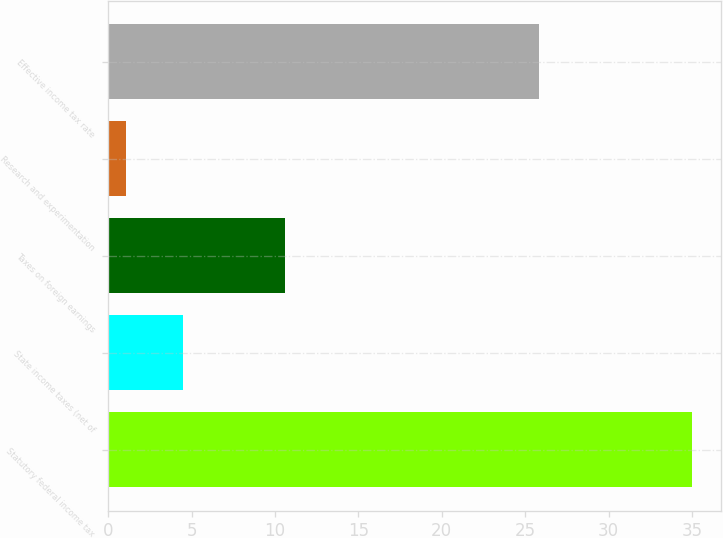Convert chart. <chart><loc_0><loc_0><loc_500><loc_500><bar_chart><fcel>Statutory federal income tax<fcel>State income taxes (net of<fcel>Taxes on foreign earnings<fcel>Research and experimentation<fcel>Effective income tax rate<nl><fcel>35<fcel>4.49<fcel>10.6<fcel>1.1<fcel>25.8<nl></chart> 